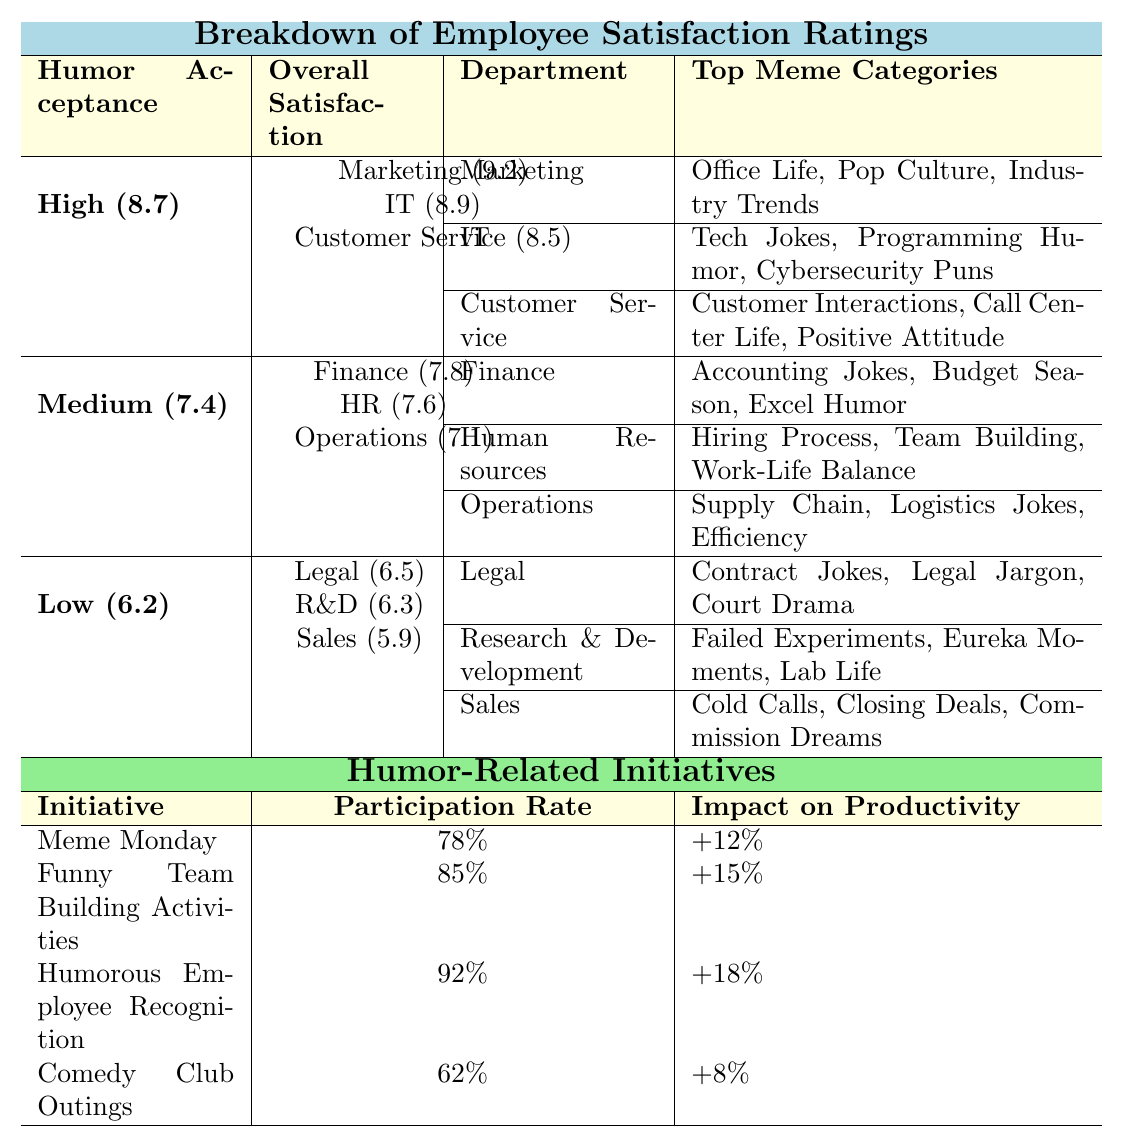What is the overall satisfaction rating for the "High" humor acceptance level? The table shows that the overall satisfaction for the "High" humor acceptance level is 8.7.
Answer: 8.7 Which department has the highest satisfaction rating among those with high humor acceptance? In the "High" category, Marketing has the highest satisfaction rating of 9.2.
Answer: Marketing What are the top meme categories for the Customer Service department? The table lists the top meme categories for Customer Service as "Customer Interactions, Call Center Life, Positive Attitude."
Answer: Customer Interactions, Call Center Life, Positive Attitude What is the satisfaction rating for the Operations department? The Operations department has a satisfaction rating of 7.1 in the "Medium" humor acceptance category.
Answer: 7.1 Is the overall satisfaction for the "Low" humor acceptance level above or below 7.0? The overall satisfaction for "Low" is 6.2, which is below 7.0.
Answer: Below Which humor-related initiative has the highest participation rate? The "Humorous Employee Recognition" initiative has the highest participation rate at 92%.
Answer: 92% What is the impact on productivity for Funny Team Building Activities? The impact on productivity for Funny Team Building Activities is +15%.
Answer: +15% If we combine the satisfaction ratings of all high humor acceptance departments, what is the total? Adding the satisfaction ratings: 9.2 (Marketing) + 8.9 (IT) + 8.5 (Customer Service) = 26.6.
Answer: 26.6 Which has the lowest satisfaction rating: Legal, R&D or Sales? Sales has the lowest satisfaction rating at 5.9 compared to Legal (6.5) and R&D (6.3).
Answer: Sales How does the impact on productivity of Meme Monday compare to the impact of Comedy Club Outings? Meme Monday has a productivity impact of +12%, while Comedy Club Outings have +8%, so Meme Monday has a higher impact.
Answer: Higher 